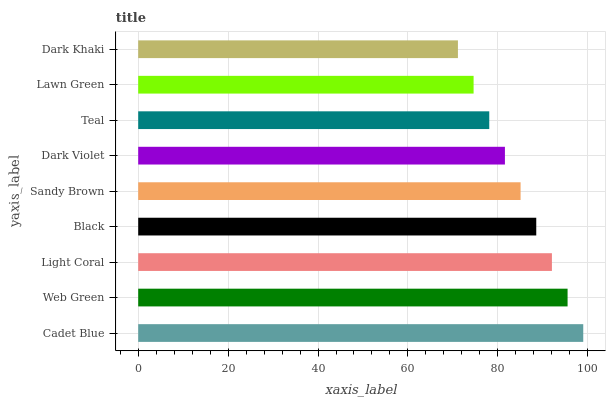Is Dark Khaki the minimum?
Answer yes or no. Yes. Is Cadet Blue the maximum?
Answer yes or no. Yes. Is Web Green the minimum?
Answer yes or no. No. Is Web Green the maximum?
Answer yes or no. No. Is Cadet Blue greater than Web Green?
Answer yes or no. Yes. Is Web Green less than Cadet Blue?
Answer yes or no. Yes. Is Web Green greater than Cadet Blue?
Answer yes or no. No. Is Cadet Blue less than Web Green?
Answer yes or no. No. Is Sandy Brown the high median?
Answer yes or no. Yes. Is Sandy Brown the low median?
Answer yes or no. Yes. Is Cadet Blue the high median?
Answer yes or no. No. Is Cadet Blue the low median?
Answer yes or no. No. 